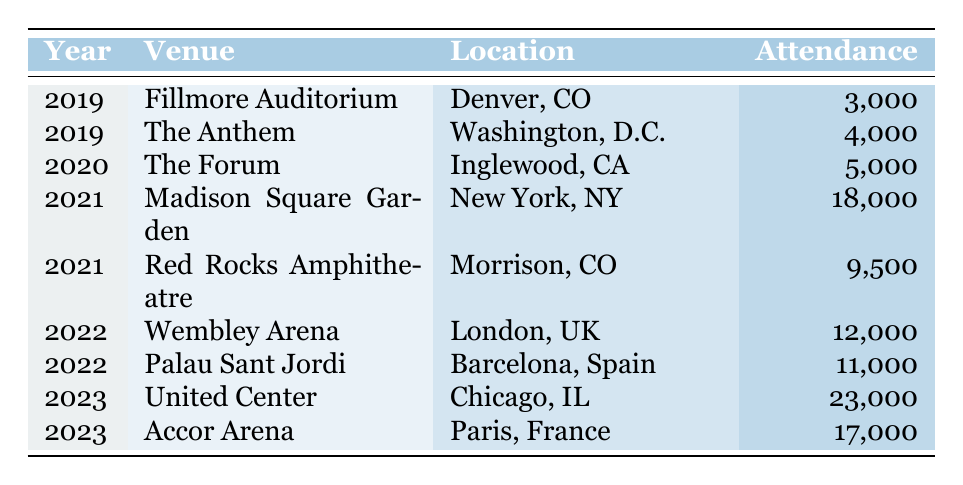What was the highest concert attendance in a single year? Looking at the attendance data, the highest attendance figure is 23,000 at the United Center in Chicago in 2023.
Answer: 23,000 Which year had the lowest concert attendance? The lowest attendance recorded is 3,000 at the Fillmore Auditorium in 2019.
Answer: 3,000 How many concerts took place in 2022? There are two concerts listed for 2022: Wembley Arena and Palau Sant Jordi.
Answer: 2 What is the total attendance for all concerts in 2021? Adding the attendances for 2021, 18,000 (Madison Square Garden) + 9,500 (Red Rocks Amphitheatre) equals 27,500.
Answer: 27,500 Did Greta Van Fleet perform at a venue in Paris? Yes, they performed at the Accor Arena in Paris in 2023.
Answer: Yes What was the average attendance for concerts in 2020 and 2021 combined? The total attendance for 2020 is 5,000, and for 2021 it is 27,500 (18,000 + 9,500). Summing these gives 32,500. There are three concerts across these two years, so the average attendance is 32,500 / 3 = approximately 10,833.
Answer: Approximately 10,833 What venue had the second highest attendance in 2023? In 2023, the United Center had the highest attendance (23,000), and the second highest was the Accor Arena with 17,000.
Answer: 17,000 Which year had a concert attendance above 15,000? The year 2021 had a concert attendance above 15,000 with Madison Square Garden at 18,000.
Answer: 2021 What is the total attendance from all venues in 2019? The concerts in 2019 had attendance figures of 3,000 at Fillmore Auditorium and 4,000 at The Anthem, summing these gives 7,000.
Answer: 7,000 Was the attendance at Red Rocks Amphitheatre higher than that at Palau Sant Jordi? Yes, 9,500 at Red Rocks Amphitheatre in 2021 is higher than 11,000 at Palau Sant Jordi in 2022.
Answer: No 